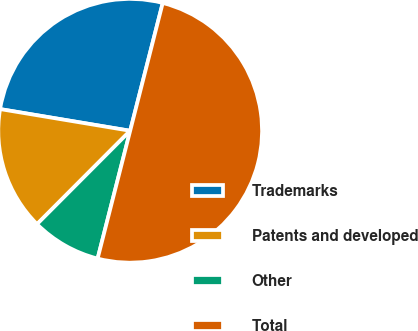Convert chart. <chart><loc_0><loc_0><loc_500><loc_500><pie_chart><fcel>Trademarks<fcel>Patents and developed<fcel>Other<fcel>Total<nl><fcel>26.34%<fcel>15.15%<fcel>8.51%<fcel>50.0%<nl></chart> 